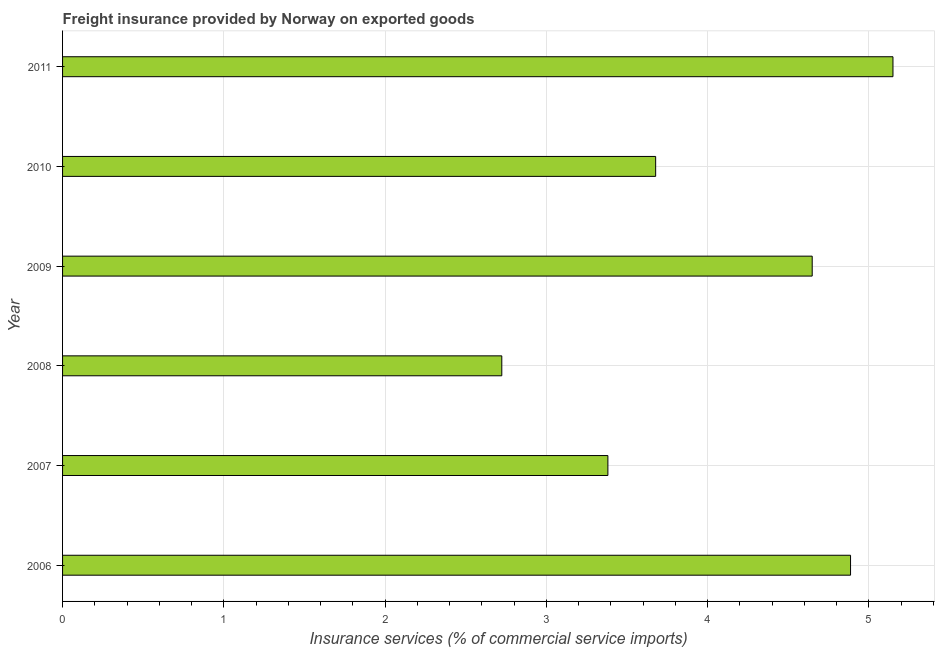Does the graph contain grids?
Give a very brief answer. Yes. What is the title of the graph?
Your answer should be compact. Freight insurance provided by Norway on exported goods . What is the label or title of the X-axis?
Ensure brevity in your answer.  Insurance services (% of commercial service imports). What is the label or title of the Y-axis?
Provide a short and direct response. Year. What is the freight insurance in 2007?
Your response must be concise. 3.38. Across all years, what is the maximum freight insurance?
Make the answer very short. 5.15. Across all years, what is the minimum freight insurance?
Ensure brevity in your answer.  2.72. In which year was the freight insurance maximum?
Your answer should be very brief. 2011. What is the sum of the freight insurance?
Ensure brevity in your answer.  24.47. What is the difference between the freight insurance in 2007 and 2008?
Ensure brevity in your answer.  0.66. What is the average freight insurance per year?
Offer a very short reply. 4.08. What is the median freight insurance?
Keep it short and to the point. 4.16. In how many years, is the freight insurance greater than 3 %?
Your answer should be very brief. 5. Do a majority of the years between 2006 and 2007 (inclusive) have freight insurance greater than 3.8 %?
Make the answer very short. No. What is the ratio of the freight insurance in 2008 to that in 2010?
Your answer should be very brief. 0.74. What is the difference between the highest and the second highest freight insurance?
Provide a short and direct response. 0.26. Is the sum of the freight insurance in 2007 and 2008 greater than the maximum freight insurance across all years?
Make the answer very short. Yes. What is the difference between the highest and the lowest freight insurance?
Provide a short and direct response. 2.43. How many bars are there?
Provide a short and direct response. 6. What is the Insurance services (% of commercial service imports) in 2006?
Your answer should be very brief. 4.89. What is the Insurance services (% of commercial service imports) of 2007?
Make the answer very short. 3.38. What is the Insurance services (% of commercial service imports) in 2008?
Provide a short and direct response. 2.72. What is the Insurance services (% of commercial service imports) in 2009?
Your answer should be very brief. 4.65. What is the Insurance services (% of commercial service imports) of 2010?
Keep it short and to the point. 3.68. What is the Insurance services (% of commercial service imports) of 2011?
Offer a very short reply. 5.15. What is the difference between the Insurance services (% of commercial service imports) in 2006 and 2007?
Offer a very short reply. 1.5. What is the difference between the Insurance services (% of commercial service imports) in 2006 and 2008?
Provide a short and direct response. 2.16. What is the difference between the Insurance services (% of commercial service imports) in 2006 and 2009?
Your response must be concise. 0.24. What is the difference between the Insurance services (% of commercial service imports) in 2006 and 2010?
Offer a terse response. 1.21. What is the difference between the Insurance services (% of commercial service imports) in 2006 and 2011?
Your response must be concise. -0.26. What is the difference between the Insurance services (% of commercial service imports) in 2007 and 2008?
Offer a very short reply. 0.66. What is the difference between the Insurance services (% of commercial service imports) in 2007 and 2009?
Offer a very short reply. -1.27. What is the difference between the Insurance services (% of commercial service imports) in 2007 and 2010?
Ensure brevity in your answer.  -0.3. What is the difference between the Insurance services (% of commercial service imports) in 2007 and 2011?
Ensure brevity in your answer.  -1.77. What is the difference between the Insurance services (% of commercial service imports) in 2008 and 2009?
Your answer should be compact. -1.93. What is the difference between the Insurance services (% of commercial service imports) in 2008 and 2010?
Your answer should be very brief. -0.95. What is the difference between the Insurance services (% of commercial service imports) in 2008 and 2011?
Keep it short and to the point. -2.43. What is the difference between the Insurance services (% of commercial service imports) in 2009 and 2010?
Your response must be concise. 0.97. What is the difference between the Insurance services (% of commercial service imports) in 2009 and 2011?
Your answer should be very brief. -0.5. What is the difference between the Insurance services (% of commercial service imports) in 2010 and 2011?
Provide a succinct answer. -1.47. What is the ratio of the Insurance services (% of commercial service imports) in 2006 to that in 2007?
Provide a succinct answer. 1.45. What is the ratio of the Insurance services (% of commercial service imports) in 2006 to that in 2008?
Your answer should be compact. 1.79. What is the ratio of the Insurance services (% of commercial service imports) in 2006 to that in 2009?
Offer a terse response. 1.05. What is the ratio of the Insurance services (% of commercial service imports) in 2006 to that in 2010?
Your answer should be very brief. 1.33. What is the ratio of the Insurance services (% of commercial service imports) in 2006 to that in 2011?
Provide a short and direct response. 0.95. What is the ratio of the Insurance services (% of commercial service imports) in 2007 to that in 2008?
Ensure brevity in your answer.  1.24. What is the ratio of the Insurance services (% of commercial service imports) in 2007 to that in 2009?
Provide a short and direct response. 0.73. What is the ratio of the Insurance services (% of commercial service imports) in 2007 to that in 2010?
Your response must be concise. 0.92. What is the ratio of the Insurance services (% of commercial service imports) in 2007 to that in 2011?
Provide a short and direct response. 0.66. What is the ratio of the Insurance services (% of commercial service imports) in 2008 to that in 2009?
Your response must be concise. 0.59. What is the ratio of the Insurance services (% of commercial service imports) in 2008 to that in 2010?
Keep it short and to the point. 0.74. What is the ratio of the Insurance services (% of commercial service imports) in 2008 to that in 2011?
Provide a short and direct response. 0.53. What is the ratio of the Insurance services (% of commercial service imports) in 2009 to that in 2010?
Your response must be concise. 1.26. What is the ratio of the Insurance services (% of commercial service imports) in 2009 to that in 2011?
Make the answer very short. 0.9. What is the ratio of the Insurance services (% of commercial service imports) in 2010 to that in 2011?
Your response must be concise. 0.71. 